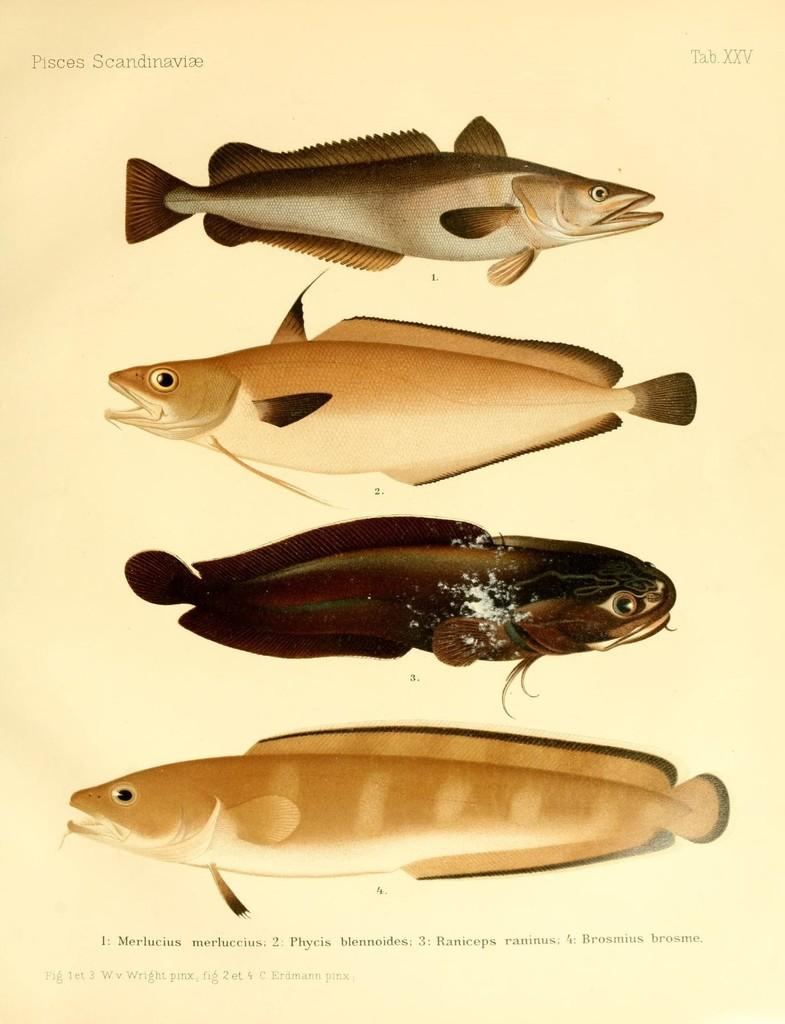What is present in the image that contains information or illustrations? There is a paper in the image. What can be found on the paper? The paper contains images of different types of fishes. Is there any text on the paper? Yes, there is text on the paper. How many sheets of paper are visible in the image? The image only shows one paper, not multiple sheets. What type of crack can be seen on the paper? There is no crack visible on the paper in the image. 